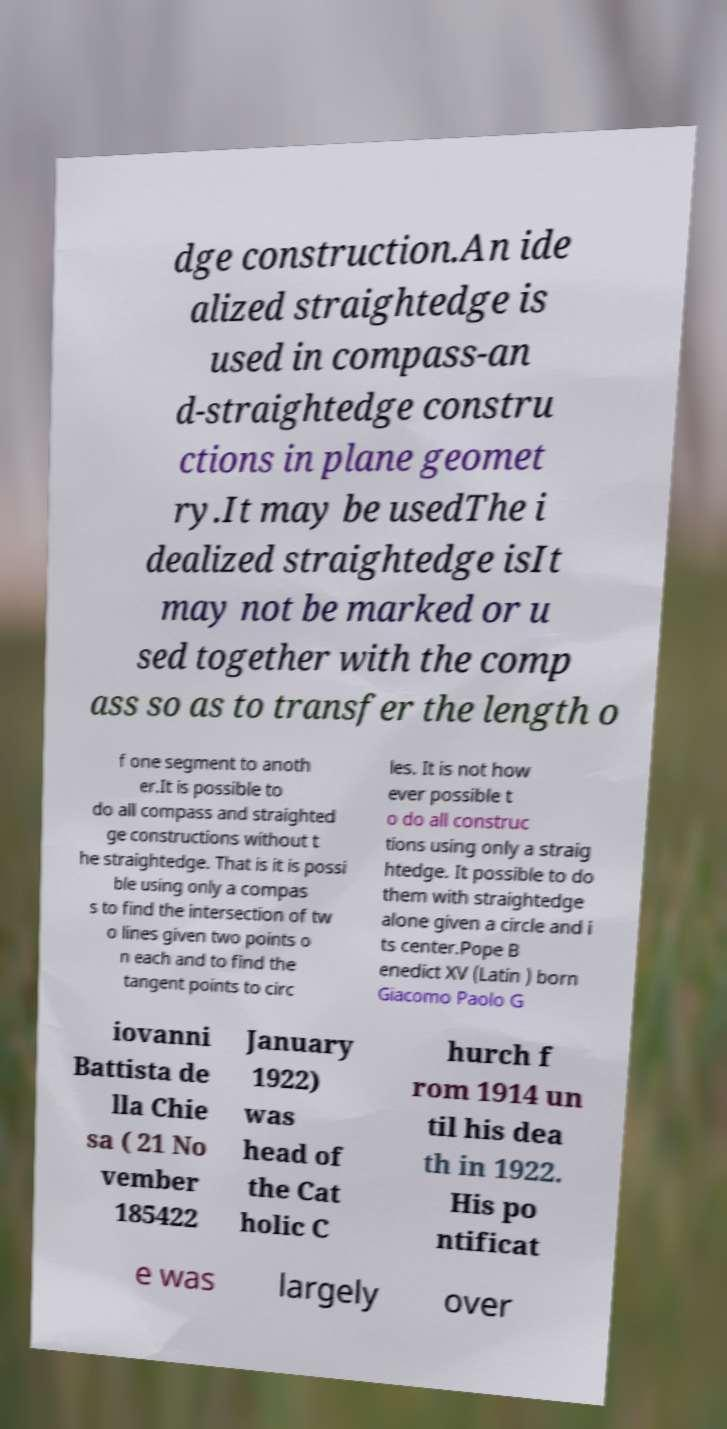What messages or text are displayed in this image? I need them in a readable, typed format. dge construction.An ide alized straightedge is used in compass-an d-straightedge constru ctions in plane geomet ry.It may be usedThe i dealized straightedge isIt may not be marked or u sed together with the comp ass so as to transfer the length o f one segment to anoth er.It is possible to do all compass and straighted ge constructions without t he straightedge. That is it is possi ble using only a compas s to find the intersection of tw o lines given two points o n each and to find the tangent points to circ les. It is not how ever possible t o do all construc tions using only a straig htedge. It possible to do them with straightedge alone given a circle and i ts center.Pope B enedict XV (Latin ) born Giacomo Paolo G iovanni Battista de lla Chie sa ( 21 No vember 185422 January 1922) was head of the Cat holic C hurch f rom 1914 un til his dea th in 1922. His po ntificat e was largely over 